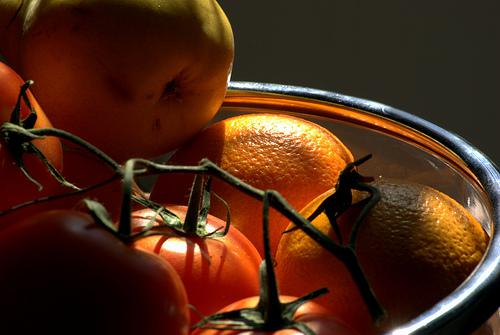Question: what citrus fruit is in the bowl?
Choices:
A. Oranges.
B. Lemons.
C. Limes.
D. Watermelon.
Answer with the letter. Answer: A Question: what color are the tomatoes?
Choices:
A. Green.
B. Red.
C. Brown.
D. Orange.
Answer with the letter. Answer: B Question: what color are the oranges in the bowl?
Choices:
A. Brown.
B. Yellow.
C. Orange.
D. Black.
Answer with the letter. Answer: C Question: who is standing behind the bowl?
Choices:
A. Man.
B. No one.
C. Woman.
D. Boy.
Answer with the letter. Answer: B Question: how many people are in this photo?
Choices:
A. One.
B. Zero.
C. Two.
D. Four.
Answer with the letter. Answer: B Question: what color is the bowl?
Choices:
A. Silver.
B. White.
C. Grey.
D. Blue.
Answer with the letter. Answer: A Question: how many silver bowls are in the photo?
Choices:
A. Two.
B. Three.
C. One.
D. Four.
Answer with the letter. Answer: C 